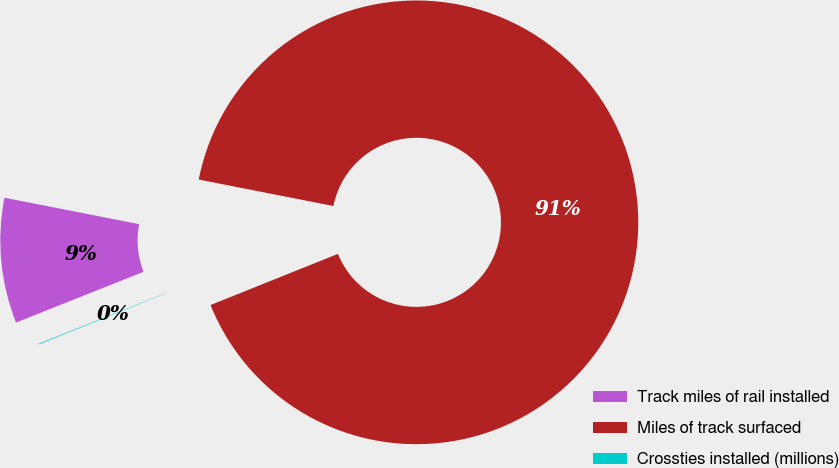Convert chart. <chart><loc_0><loc_0><loc_500><loc_500><pie_chart><fcel>Track miles of rail installed<fcel>Miles of track surfaced<fcel>Crossties installed (millions)<nl><fcel>9.12%<fcel>90.83%<fcel>0.05%<nl></chart> 